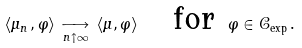<formula> <loc_0><loc_0><loc_500><loc_500>\left \langle \mu _ { n \, } , \varphi \right \rangle \, \underset { n \uparrow \infty } { \longrightarrow } \, \left \langle \mu , \varphi \right \rangle \quad \text {for } \, \varphi \in \mathcal { C } _ { \exp \, } .</formula> 